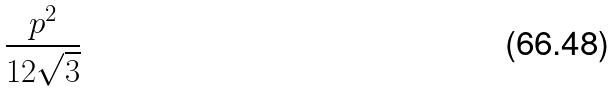Convert formula to latex. <formula><loc_0><loc_0><loc_500><loc_500>\frac { p ^ { 2 } } { 1 2 \sqrt { 3 } }</formula> 